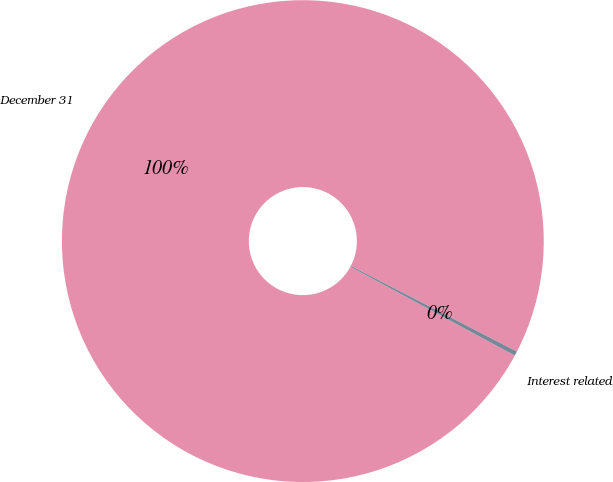Convert chart. <chart><loc_0><loc_0><loc_500><loc_500><pie_chart><fcel>December 31<fcel>Interest related<nl><fcel>99.7%<fcel>0.3%<nl></chart> 